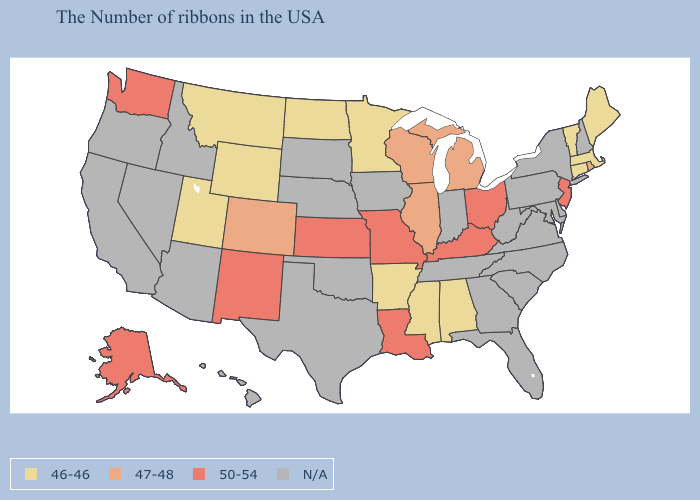What is the lowest value in the USA?
Quick response, please. 46-46. Name the states that have a value in the range N/A?
Give a very brief answer. New Hampshire, New York, Delaware, Maryland, Pennsylvania, Virginia, North Carolina, South Carolina, West Virginia, Florida, Georgia, Indiana, Tennessee, Iowa, Nebraska, Oklahoma, Texas, South Dakota, Arizona, Idaho, Nevada, California, Oregon, Hawaii. What is the value of Connecticut?
Give a very brief answer. 46-46. Which states hav the highest value in the Northeast?
Answer briefly. New Jersey. What is the value of Maine?
Concise answer only. 46-46. Does the map have missing data?
Short answer required. Yes. What is the value of Texas?
Give a very brief answer. N/A. Does Vermont have the highest value in the USA?
Write a very short answer. No. What is the value of Nebraska?
Quick response, please. N/A. Name the states that have a value in the range 46-46?
Quick response, please. Maine, Massachusetts, Vermont, Connecticut, Alabama, Mississippi, Arkansas, Minnesota, North Dakota, Wyoming, Utah, Montana. What is the value of Washington?
Short answer required. 50-54. 